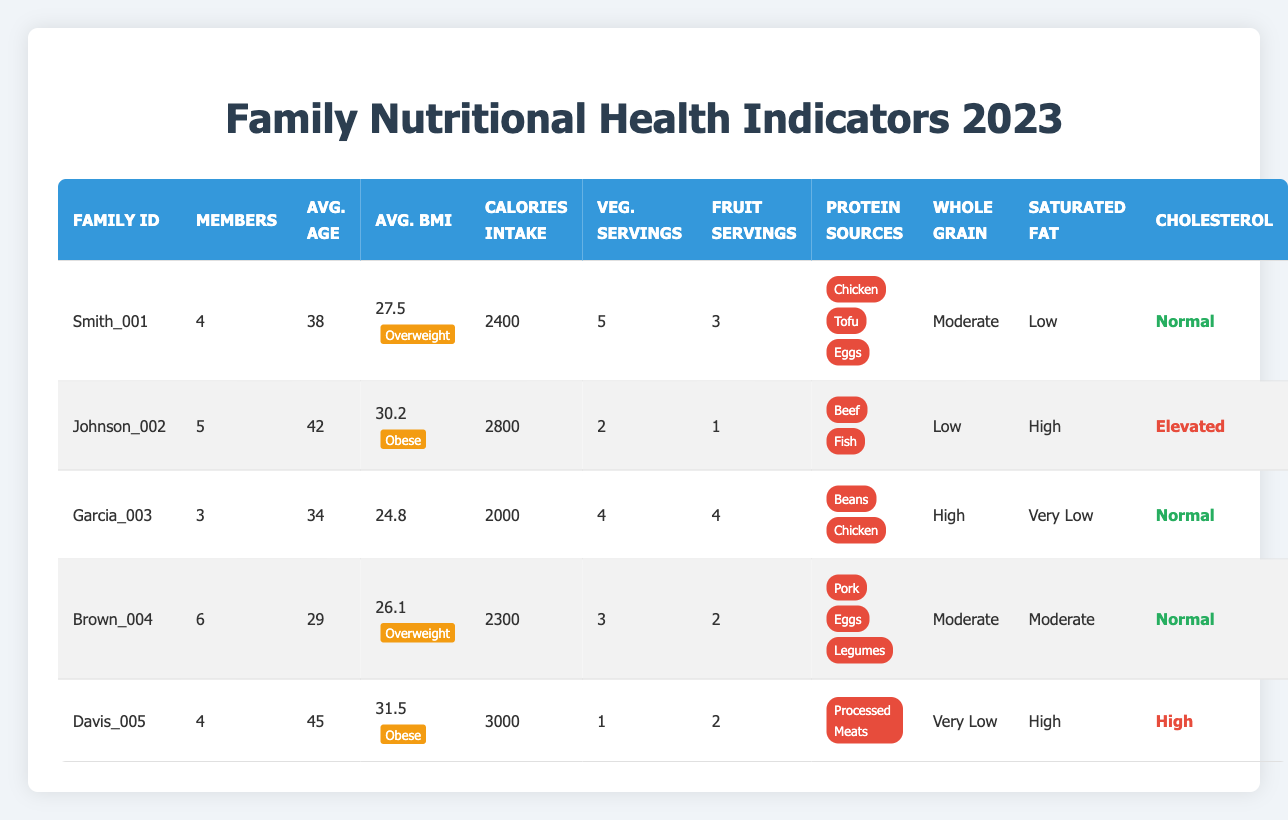What is the average BMI of the families listed? To find the average BMI, sum the average BMIs of all families (27.5 + 30.2 + 24.8 + 26.1 + 31.5 = 140.1) and divide by the number of families (5). The average BMI is 140.1/5 = 28.02.
Answer: 28.02 Which family has the highest calorie intake? By reviewing the calorie intake column, Davis_005 has the highest value at 3000 calories.
Answer: Davis_005 How many families consume high whole grain? Looking at the whole grain consumption column, only Garcia_003 and Brown_004 are categorized as "High." Therefore, there are 2 families.
Answer: 2 Does the Johnson family have an elevated cholesterol level? The cholesterol level for Johnson_002 is indicated as "Elevated." Thus, the answer is yes.
Answer: Yes What is the total number of vegetable servings consumed by all families? Adding the vegetable servings of all families: (5 + 2 + 4 + 3 + 1 = 15). Therefore, the total vegetable servings is 15.
Answer: 15 Which family has a normal cholesterol level? The families that show a normal cholesterol level are Smith_001, Garcia_003, and Brown_004. Hence, multiple families have normal levels.
Answer: Smith_001, Garcia_003, Brown_004 Is the average age of families older than 40? The average ages of the families are 38, 42, 34, 29, and 45. The average age calculated is (38 + 42 + 34 + 29 + 45) / 5 = 37.6, which is less than 40. Thus, the answer is no.
Answer: No Which family has the most protein sources? Smith_001 has 3 protein sources (Chicken, Tofu, Eggs), while other families have less than or equal to this number. Therefore, Smith_001 has the most.
Answer: Smith_001 How many families have a low saturated fat intake? From the saturated fat intake column, Smith_001 and Garcia_003 are listed as having low or very low saturated fat intake. Therefore, there are 2 such families.
Answer: 2 